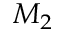Convert formula to latex. <formula><loc_0><loc_0><loc_500><loc_500>M _ { 2 }</formula> 